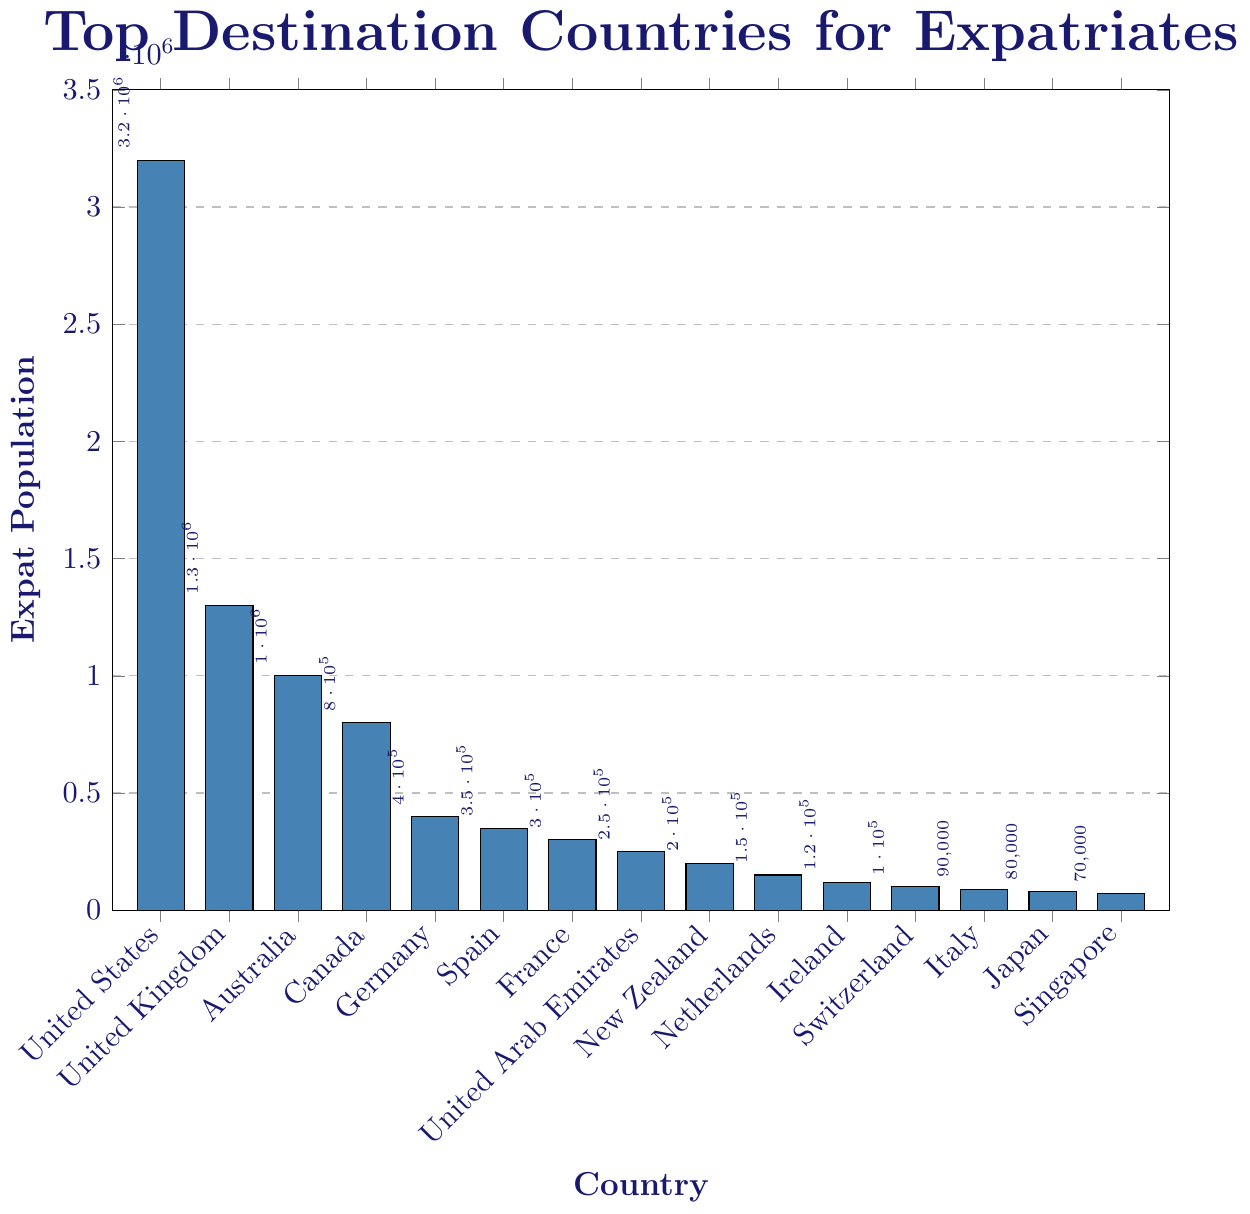What is the country with the highest expatriate population from your home country? The bar representing the United States is the highest, indicating it has the largest expatriate population.
Answer: United States How many more expatriates live in the United States compared to the United Kingdom? The bar for the United States reaches 3,200,000 while the bar for the United Kingdom reaches 1,300,000. The difference is 3,200,000 - 1,300,000.
Answer: 1,900,000 Compare the expatriate populations of Germany and Canada. Which country has fewer expatriates? The bar for Germany is at 400,000, whereas the bar for Canada is at 800,000. Therefore, Germany has fewer expatriates.
Answer: Germany Which countries have expatriate populations less than 300,000? The bars for United Arab Emirates, New Zealand, Netherlands, Ireland, Switzerland, Italy, Japan, and Singapore are all below the 300,000 mark.
Answer: United Arab Emirates, New Zealand, Netherlands, Ireland, Switzerland, Italy, Japan, Singapore What is the total expatriate population across Spain, France, and Japan? The populations are 350,000 (Spain), 300,000 (France), and 80,000 (Japan). Summing these gives 350,000 + 300,000 + 80,000.
Answer: 730,000 Which country has the smallest expatriate population? The shortest bar is for Singapore, indicating it has the smallest expatriate population.
Answer: Singapore Are there more expatriates in Australia or Canada? The bar for Australia reaches 1,000,000 while Canada reaches 800,000. Therefore, Australia has more expatriates.
Answer: Australia How does the expatriate population in Ireland compare to that in Switzerland? The bar for Ireland reaches 120,000 whereas the bar for Switzerland reaches 100,000, meaning Ireland has a higher expatriate population.
Answer: Ireland What is the combined expatriate population of New Zealand and Switzerland? The populations are 200,000 (New Zealand) and 100,000 (Switzerland). Summing these gives 200,000 + 100,000.
Answer: 300,000 How many times greater is the expatriate population in the United States compared to that in Singapore? The population in the United States is 3,200,000, and in Singapore, it is 70,000. Dividing these numbers gives 3,200,000 / 70,000.
Answer: Approximately 45.7 